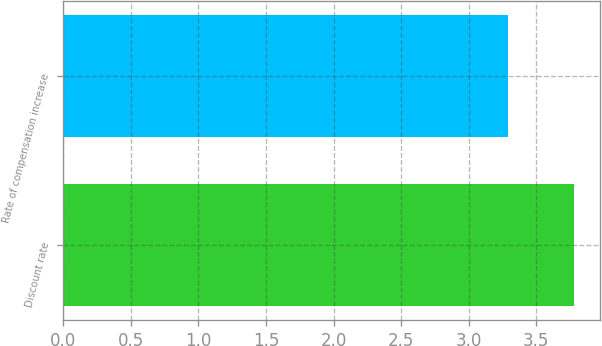Convert chart to OTSL. <chart><loc_0><loc_0><loc_500><loc_500><bar_chart><fcel>Discount rate<fcel>Rate of compensation increase<nl><fcel>3.78<fcel>3.29<nl></chart> 